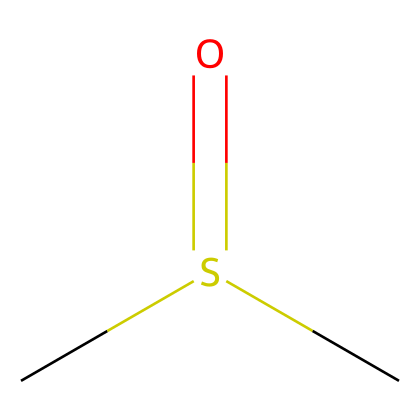What is the molecular formula of dimethyl sulfoxide? The SMILES representation indicates two carbon atoms (C), one sulfur atom (S), and one oxygen atom (O). Thus, the molecular formula consists of two carbons, one sulfur, and one oxygen.
Answer: C2H6OS How many hydrogen atoms are in dimethyl sulfoxide? The SMILES representation includes two methyl groups (CS), each contributing three hydrogen atoms. Therefore, the total number of hydrogen atoms is six.
Answer: 6 What type of functional group is present in dimethyl sulfoxide? The presence of the sulfoxide functional group, identifiable by the sulfur atom bonded to an oxygen atom, indicates that the compound is classified as a sulfoxide.
Answer: sulfoxide What is the oxidation state of sulfur in dimethyl sulfoxide? In dimethyl sulfoxide, sulfur is bonded to one oxygen with a double bond and two carbon atoms, resulting in an oxidation state of +2 for sulfur.
Answer: +2 What is the bond type between sulfur and oxygen in dimethyl sulfoxide? The structure shows a double bond between sulfur and oxygen (S=O), indicating that this bond type is a double bond.
Answer: double bond How many total atoms are in the dimethyl sulfoxide molecule? By summing the atoms present: 2 carbon, 6 hydrogen, 1 sulfur, and 1 oxygen, the total number of atoms in the molecule is 10.
Answer: 10 